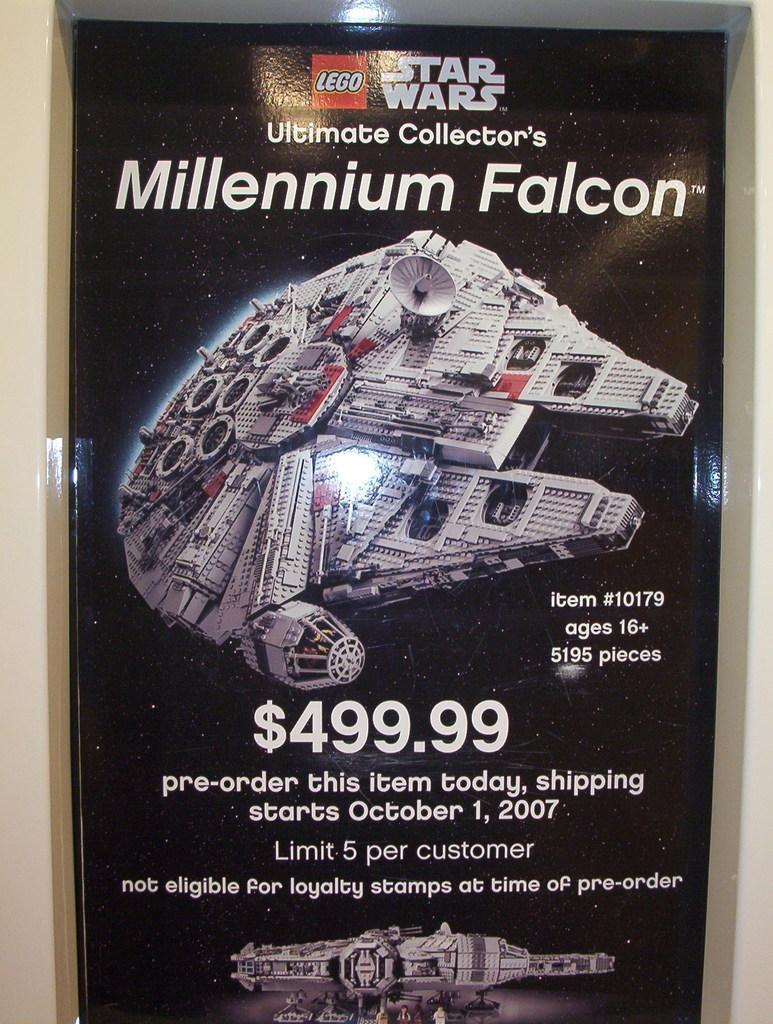<image>
Describe the image concisely. A package for Star Wars and the Millennium Falcon. 